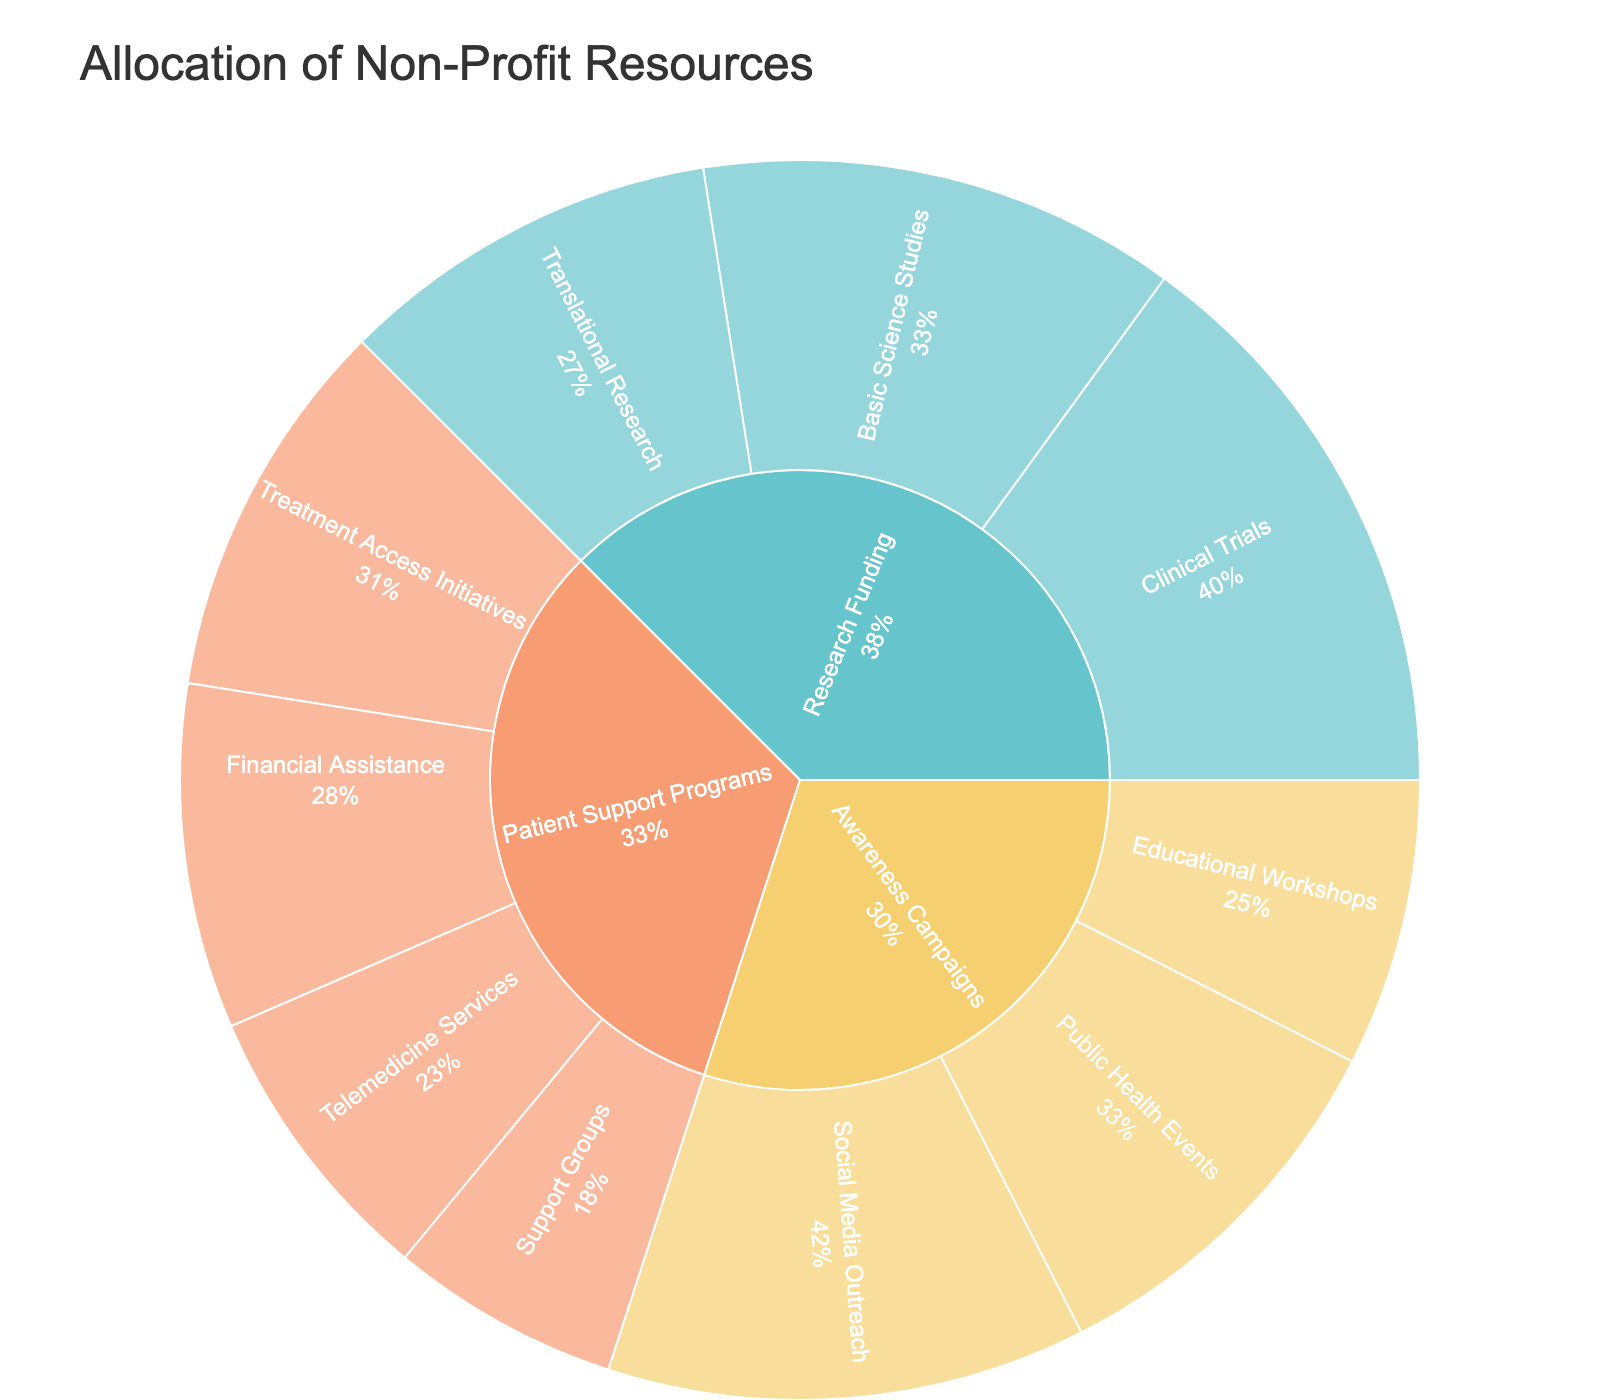What's the total value allocated to Awareness Campaigns? The total value is the sum of all subcategories under Awareness Campaigns: Social Media Outreach (25) + Public Health Events (20) + Educational Workshops (15) = 60.
Answer: 60 Which subcategory under Research Funding has the highest value? Clinical Trials has the highest value among the subcategories of Research Funding with a value of 30.
Answer: Clinical Trials What is the percentage of Financial Assistance in Patient Support Programs? The total value of Patient Support Programs is the sum of its subcategories: Financial Assistance (18) + Support Groups (12) + Telemedicine Services (15) + Treatment Access Initiatives (20) = 65. The percentage of Financial Assistance is (18 / 65) * 100 ≈ 27.69%.
Answer: 27.69% How does the value of Translational Research compare to Basic Science Studies? Translational Research has a value of 20, while Basic Science Studies have a value of 25. Therefore, Translational Research has a lower value than Basic Science Studies.
Answer: Lower What percentage of the total resources is allocated to Research Funding? The total value of all resources is the sum of values in Awareness Campaigns (60) + Research Funding (75) + Patient Support Programs (65) = 200. The percentage allocated to Research Funding is (75 / 200) * 100 = 37.5%.
Answer: 37.5% Which category has the least total value allocated? Awareness Campaigns have the least total value allocated with 60, compared to Research Funding (75) and Patient Support Programs (65).
Answer: Awareness Campaigns What is the combined value of Educational Workshops and Telemedicine Services? The combined value is the sum of Educational Workshops (15) and Telemedicine Services (15), which is 15 + 15 = 30.
Answer: 30 What is the difference in value between Public Health Events and Support Groups? The difference in value is calculated as the value of Public Health Events (20) minus the value of Support Groups (12), which is 20 - 12 = 8.
Answer: 8 Which category has the highest variety of subcategories? Patient Support Programs have the highest variety of subcategories with four: Financial Assistance, Support Groups, Telemedicine Services, and Treatment Access Initiatives.
Answer: Patient Support Programs What percentage of Research Funding is allocated to Clinical Trials? The total value of Research Funding is 75. The percentage allocated to Clinical Trials is (30 / 75) * 100 = 40%.
Answer: 40% 